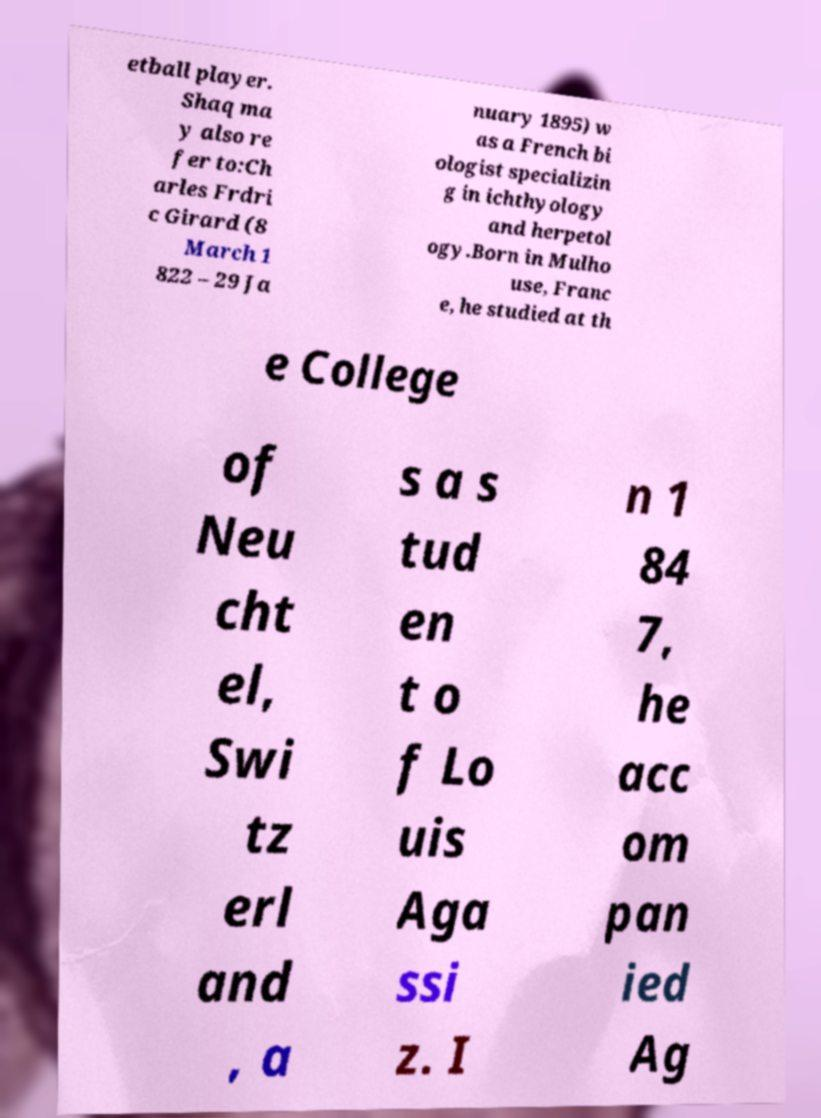Could you extract and type out the text from this image? etball player. Shaq ma y also re fer to:Ch arles Frdri c Girard (8 March 1 822 – 29 Ja nuary 1895) w as a French bi ologist specializin g in ichthyology and herpetol ogy.Born in Mulho use, Franc e, he studied at th e College of Neu cht el, Swi tz erl and , a s a s tud en t o f Lo uis Aga ssi z. I n 1 84 7, he acc om pan ied Ag 